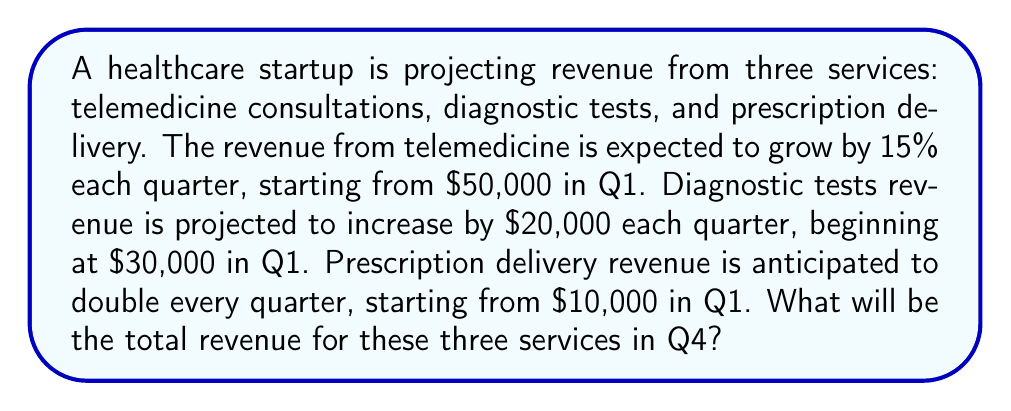Help me with this question. Let's calculate the revenue for each service in Q4:

1. Telemedicine consultations:
   Q1: $50,000
   Q2: $50,000 * 1.15 = $57,500
   Q3: $57,500 * 1.15 = $66,125
   Q4: $66,125 * 1.15 = $76,043.75

2. Diagnostic tests:
   Q1: $30,000
   Q2: $30,000 + $20,000 = $50,000
   Q3: $50,000 + $20,000 = $70,000
   Q4: $70,000 + $20,000 = $90,000

3. Prescription delivery:
   Q1: $10,000
   Q2: $10,000 * 2 = $20,000
   Q3: $20,000 * 2 = $40,000
   Q4: $40,000 * 2 = $80,000

Total revenue in Q4:
$$76,043.75 + 90,000 + 80,000 = $246,043.75$$
Answer: $246,043.75 